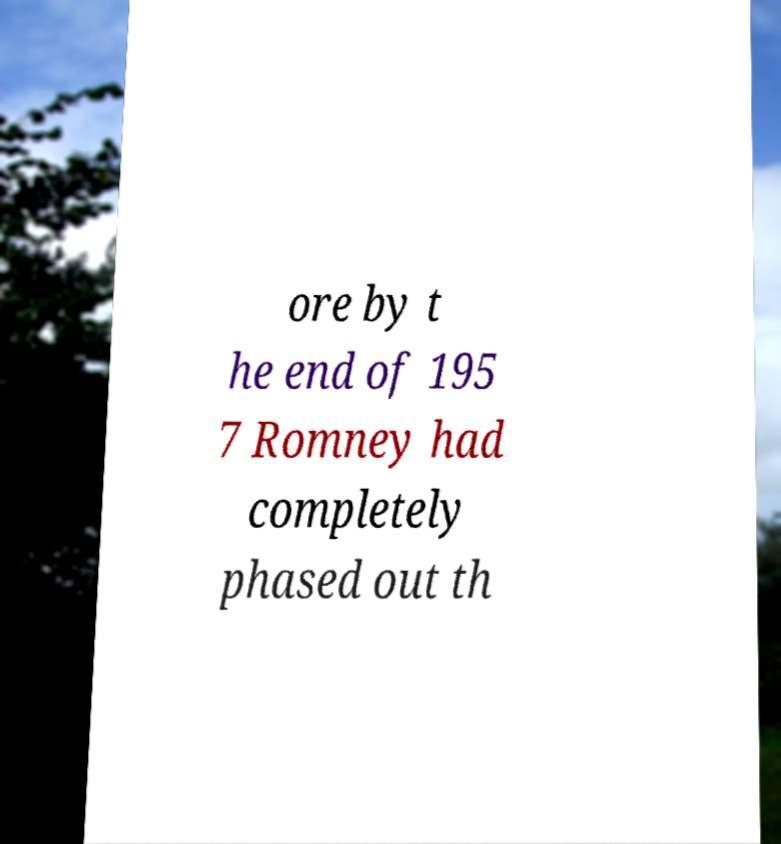Can you accurately transcribe the text from the provided image for me? ore by t he end of 195 7 Romney had completely phased out th 